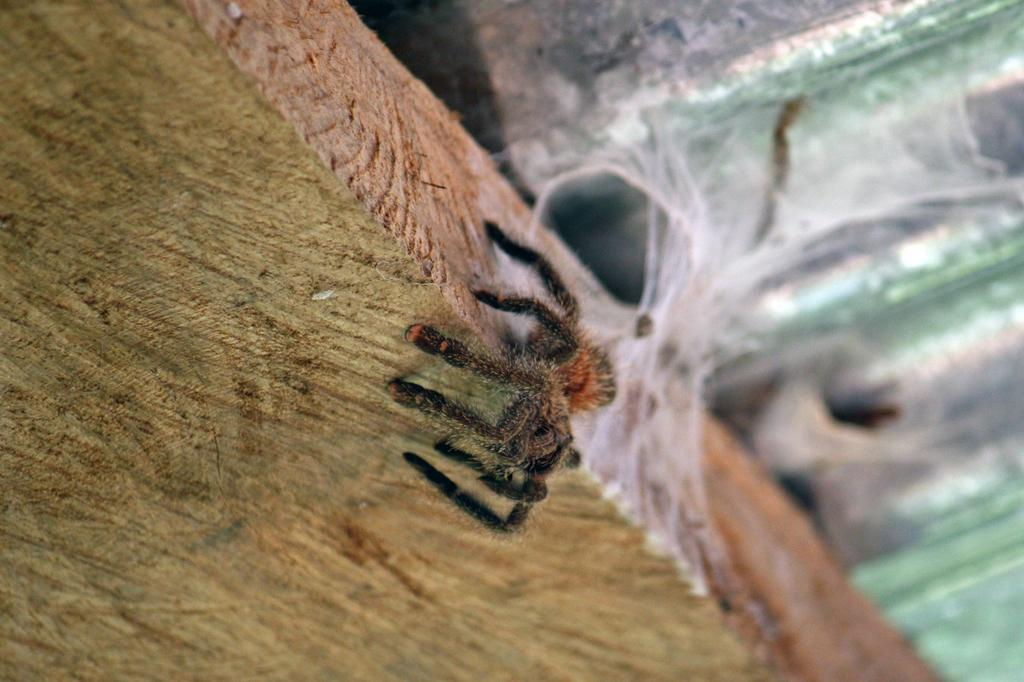What type of flooring is present in the image? The flooring in the image is wooden. Is there any specific object or creature visible on the wooden floor? There may be a spider visible on the wooden floor. What type of hammer is being used on the sidewalk in the image? There is no hammer or sidewalk present in the image; it only features a wooden floor. 